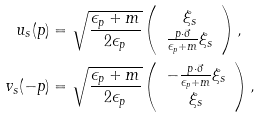<formula> <loc_0><loc_0><loc_500><loc_500>u _ { s } ( p ) & = \sqrt { \frac { \epsilon _ { p } + m } { 2 \epsilon _ { p } } } \left ( \begin{array} { c } \xi _ { s } \\ \frac { p \cdot \vec { \sigma } } { \epsilon _ { p } + m } \xi _ { s } \end{array} \right ) , \\ v _ { s } ( - p ) & = \sqrt { \frac { \epsilon _ { p } + m } { 2 \epsilon _ { p } } } \left ( \begin{array} { c } - \frac { p \cdot \vec { \sigma } } { \epsilon _ { p } + m } \xi _ { s } \\ \xi _ { s } \end{array} \right ) ,</formula> 